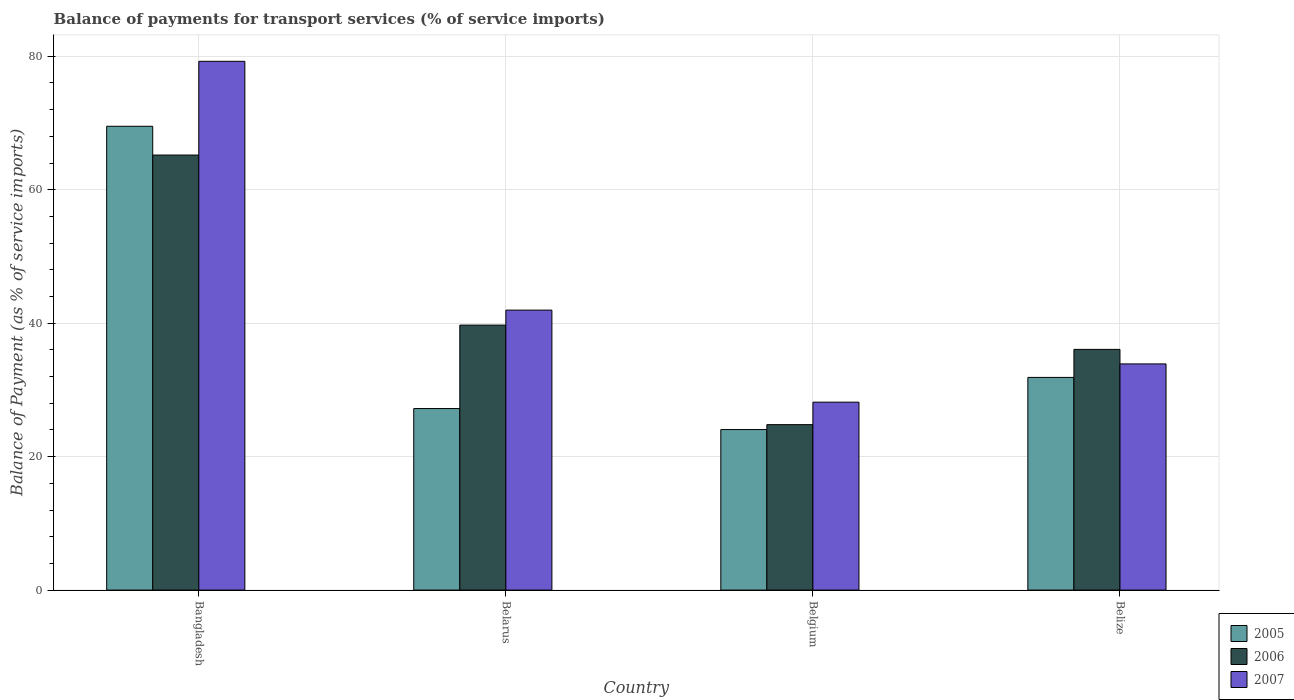How many different coloured bars are there?
Offer a terse response. 3. How many bars are there on the 3rd tick from the left?
Your answer should be very brief. 3. What is the balance of payments for transport services in 2006 in Belize?
Provide a short and direct response. 36.07. Across all countries, what is the maximum balance of payments for transport services in 2007?
Ensure brevity in your answer.  79.24. Across all countries, what is the minimum balance of payments for transport services in 2006?
Ensure brevity in your answer.  24.79. What is the total balance of payments for transport services in 2007 in the graph?
Provide a succinct answer. 183.25. What is the difference between the balance of payments for transport services in 2005 in Belarus and that in Belize?
Offer a terse response. -4.67. What is the difference between the balance of payments for transport services in 2005 in Belize and the balance of payments for transport services in 2006 in Belgium?
Your response must be concise. 7.08. What is the average balance of payments for transport services in 2006 per country?
Your answer should be very brief. 41.44. What is the difference between the balance of payments for transport services of/in 2007 and balance of payments for transport services of/in 2006 in Belize?
Your response must be concise. -2.18. What is the ratio of the balance of payments for transport services in 2007 in Bangladesh to that in Belgium?
Your answer should be very brief. 2.81. What is the difference between the highest and the second highest balance of payments for transport services in 2005?
Offer a terse response. -42.3. What is the difference between the highest and the lowest balance of payments for transport services in 2005?
Your answer should be very brief. 45.45. What does the 2nd bar from the left in Bangladesh represents?
Keep it short and to the point. 2006. What does the 2nd bar from the right in Belgium represents?
Offer a very short reply. 2006. Is it the case that in every country, the sum of the balance of payments for transport services in 2006 and balance of payments for transport services in 2005 is greater than the balance of payments for transport services in 2007?
Your answer should be compact. Yes. How many bars are there?
Your answer should be very brief. 12. How many countries are there in the graph?
Offer a terse response. 4. How are the legend labels stacked?
Keep it short and to the point. Vertical. What is the title of the graph?
Your answer should be very brief. Balance of payments for transport services (% of service imports). What is the label or title of the X-axis?
Your answer should be very brief. Country. What is the label or title of the Y-axis?
Make the answer very short. Balance of Payment (as % of service imports). What is the Balance of Payment (as % of service imports) in 2005 in Bangladesh?
Your answer should be very brief. 69.5. What is the Balance of Payment (as % of service imports) in 2006 in Bangladesh?
Ensure brevity in your answer.  65.2. What is the Balance of Payment (as % of service imports) of 2007 in Bangladesh?
Offer a terse response. 79.24. What is the Balance of Payment (as % of service imports) in 2005 in Belarus?
Your answer should be compact. 27.2. What is the Balance of Payment (as % of service imports) of 2006 in Belarus?
Your answer should be very brief. 39.71. What is the Balance of Payment (as % of service imports) of 2007 in Belarus?
Ensure brevity in your answer.  41.96. What is the Balance of Payment (as % of service imports) in 2005 in Belgium?
Give a very brief answer. 24.06. What is the Balance of Payment (as % of service imports) in 2006 in Belgium?
Give a very brief answer. 24.79. What is the Balance of Payment (as % of service imports) in 2007 in Belgium?
Give a very brief answer. 28.16. What is the Balance of Payment (as % of service imports) in 2005 in Belize?
Offer a very short reply. 31.87. What is the Balance of Payment (as % of service imports) in 2006 in Belize?
Your answer should be very brief. 36.07. What is the Balance of Payment (as % of service imports) of 2007 in Belize?
Make the answer very short. 33.89. Across all countries, what is the maximum Balance of Payment (as % of service imports) in 2005?
Provide a short and direct response. 69.5. Across all countries, what is the maximum Balance of Payment (as % of service imports) of 2006?
Your answer should be very brief. 65.2. Across all countries, what is the maximum Balance of Payment (as % of service imports) of 2007?
Ensure brevity in your answer.  79.24. Across all countries, what is the minimum Balance of Payment (as % of service imports) of 2005?
Provide a succinct answer. 24.06. Across all countries, what is the minimum Balance of Payment (as % of service imports) in 2006?
Your answer should be very brief. 24.79. Across all countries, what is the minimum Balance of Payment (as % of service imports) of 2007?
Your answer should be compact. 28.16. What is the total Balance of Payment (as % of service imports) in 2005 in the graph?
Keep it short and to the point. 152.64. What is the total Balance of Payment (as % of service imports) of 2006 in the graph?
Your answer should be compact. 165.77. What is the total Balance of Payment (as % of service imports) in 2007 in the graph?
Your answer should be compact. 183.25. What is the difference between the Balance of Payment (as % of service imports) in 2005 in Bangladesh and that in Belarus?
Your response must be concise. 42.3. What is the difference between the Balance of Payment (as % of service imports) of 2006 in Bangladesh and that in Belarus?
Make the answer very short. 25.48. What is the difference between the Balance of Payment (as % of service imports) in 2007 in Bangladesh and that in Belarus?
Your answer should be very brief. 37.28. What is the difference between the Balance of Payment (as % of service imports) in 2005 in Bangladesh and that in Belgium?
Your answer should be very brief. 45.45. What is the difference between the Balance of Payment (as % of service imports) of 2006 in Bangladesh and that in Belgium?
Offer a terse response. 40.4. What is the difference between the Balance of Payment (as % of service imports) in 2007 in Bangladesh and that in Belgium?
Offer a terse response. 51.08. What is the difference between the Balance of Payment (as % of service imports) of 2005 in Bangladesh and that in Belize?
Offer a very short reply. 37.63. What is the difference between the Balance of Payment (as % of service imports) of 2006 in Bangladesh and that in Belize?
Your answer should be compact. 29.12. What is the difference between the Balance of Payment (as % of service imports) of 2007 in Bangladesh and that in Belize?
Ensure brevity in your answer.  45.35. What is the difference between the Balance of Payment (as % of service imports) in 2005 in Belarus and that in Belgium?
Make the answer very short. 3.15. What is the difference between the Balance of Payment (as % of service imports) in 2006 in Belarus and that in Belgium?
Offer a very short reply. 14.92. What is the difference between the Balance of Payment (as % of service imports) in 2007 in Belarus and that in Belgium?
Your answer should be compact. 13.79. What is the difference between the Balance of Payment (as % of service imports) in 2005 in Belarus and that in Belize?
Offer a terse response. -4.67. What is the difference between the Balance of Payment (as % of service imports) of 2006 in Belarus and that in Belize?
Keep it short and to the point. 3.64. What is the difference between the Balance of Payment (as % of service imports) of 2007 in Belarus and that in Belize?
Provide a short and direct response. 8.06. What is the difference between the Balance of Payment (as % of service imports) in 2005 in Belgium and that in Belize?
Your answer should be very brief. -7.81. What is the difference between the Balance of Payment (as % of service imports) in 2006 in Belgium and that in Belize?
Your answer should be compact. -11.28. What is the difference between the Balance of Payment (as % of service imports) in 2007 in Belgium and that in Belize?
Ensure brevity in your answer.  -5.73. What is the difference between the Balance of Payment (as % of service imports) of 2005 in Bangladesh and the Balance of Payment (as % of service imports) of 2006 in Belarus?
Make the answer very short. 29.79. What is the difference between the Balance of Payment (as % of service imports) in 2005 in Bangladesh and the Balance of Payment (as % of service imports) in 2007 in Belarus?
Offer a terse response. 27.55. What is the difference between the Balance of Payment (as % of service imports) of 2006 in Bangladesh and the Balance of Payment (as % of service imports) of 2007 in Belarus?
Your answer should be compact. 23.24. What is the difference between the Balance of Payment (as % of service imports) of 2005 in Bangladesh and the Balance of Payment (as % of service imports) of 2006 in Belgium?
Your response must be concise. 44.71. What is the difference between the Balance of Payment (as % of service imports) of 2005 in Bangladesh and the Balance of Payment (as % of service imports) of 2007 in Belgium?
Offer a very short reply. 41.34. What is the difference between the Balance of Payment (as % of service imports) in 2006 in Bangladesh and the Balance of Payment (as % of service imports) in 2007 in Belgium?
Offer a terse response. 37.03. What is the difference between the Balance of Payment (as % of service imports) in 2005 in Bangladesh and the Balance of Payment (as % of service imports) in 2006 in Belize?
Your response must be concise. 33.43. What is the difference between the Balance of Payment (as % of service imports) in 2005 in Bangladesh and the Balance of Payment (as % of service imports) in 2007 in Belize?
Ensure brevity in your answer.  35.61. What is the difference between the Balance of Payment (as % of service imports) in 2006 in Bangladesh and the Balance of Payment (as % of service imports) in 2007 in Belize?
Your response must be concise. 31.3. What is the difference between the Balance of Payment (as % of service imports) of 2005 in Belarus and the Balance of Payment (as % of service imports) of 2006 in Belgium?
Offer a very short reply. 2.41. What is the difference between the Balance of Payment (as % of service imports) of 2005 in Belarus and the Balance of Payment (as % of service imports) of 2007 in Belgium?
Offer a very short reply. -0.96. What is the difference between the Balance of Payment (as % of service imports) of 2006 in Belarus and the Balance of Payment (as % of service imports) of 2007 in Belgium?
Provide a short and direct response. 11.55. What is the difference between the Balance of Payment (as % of service imports) of 2005 in Belarus and the Balance of Payment (as % of service imports) of 2006 in Belize?
Ensure brevity in your answer.  -8.87. What is the difference between the Balance of Payment (as % of service imports) in 2005 in Belarus and the Balance of Payment (as % of service imports) in 2007 in Belize?
Make the answer very short. -6.69. What is the difference between the Balance of Payment (as % of service imports) of 2006 in Belarus and the Balance of Payment (as % of service imports) of 2007 in Belize?
Keep it short and to the point. 5.82. What is the difference between the Balance of Payment (as % of service imports) in 2005 in Belgium and the Balance of Payment (as % of service imports) in 2006 in Belize?
Your response must be concise. -12.02. What is the difference between the Balance of Payment (as % of service imports) of 2005 in Belgium and the Balance of Payment (as % of service imports) of 2007 in Belize?
Keep it short and to the point. -9.84. What is the difference between the Balance of Payment (as % of service imports) in 2006 in Belgium and the Balance of Payment (as % of service imports) in 2007 in Belize?
Your response must be concise. -9.1. What is the average Balance of Payment (as % of service imports) in 2005 per country?
Give a very brief answer. 38.16. What is the average Balance of Payment (as % of service imports) of 2006 per country?
Your answer should be very brief. 41.44. What is the average Balance of Payment (as % of service imports) in 2007 per country?
Ensure brevity in your answer.  45.81. What is the difference between the Balance of Payment (as % of service imports) of 2005 and Balance of Payment (as % of service imports) of 2006 in Bangladesh?
Provide a succinct answer. 4.31. What is the difference between the Balance of Payment (as % of service imports) in 2005 and Balance of Payment (as % of service imports) in 2007 in Bangladesh?
Offer a terse response. -9.74. What is the difference between the Balance of Payment (as % of service imports) in 2006 and Balance of Payment (as % of service imports) in 2007 in Bangladesh?
Provide a succinct answer. -14.04. What is the difference between the Balance of Payment (as % of service imports) in 2005 and Balance of Payment (as % of service imports) in 2006 in Belarus?
Keep it short and to the point. -12.51. What is the difference between the Balance of Payment (as % of service imports) of 2005 and Balance of Payment (as % of service imports) of 2007 in Belarus?
Provide a short and direct response. -14.75. What is the difference between the Balance of Payment (as % of service imports) in 2006 and Balance of Payment (as % of service imports) in 2007 in Belarus?
Make the answer very short. -2.24. What is the difference between the Balance of Payment (as % of service imports) in 2005 and Balance of Payment (as % of service imports) in 2006 in Belgium?
Offer a terse response. -0.74. What is the difference between the Balance of Payment (as % of service imports) of 2005 and Balance of Payment (as % of service imports) of 2007 in Belgium?
Make the answer very short. -4.11. What is the difference between the Balance of Payment (as % of service imports) of 2006 and Balance of Payment (as % of service imports) of 2007 in Belgium?
Keep it short and to the point. -3.37. What is the difference between the Balance of Payment (as % of service imports) in 2005 and Balance of Payment (as % of service imports) in 2006 in Belize?
Your answer should be very brief. -4.2. What is the difference between the Balance of Payment (as % of service imports) in 2005 and Balance of Payment (as % of service imports) in 2007 in Belize?
Your response must be concise. -2.02. What is the difference between the Balance of Payment (as % of service imports) of 2006 and Balance of Payment (as % of service imports) of 2007 in Belize?
Make the answer very short. 2.18. What is the ratio of the Balance of Payment (as % of service imports) of 2005 in Bangladesh to that in Belarus?
Your answer should be very brief. 2.55. What is the ratio of the Balance of Payment (as % of service imports) in 2006 in Bangladesh to that in Belarus?
Offer a very short reply. 1.64. What is the ratio of the Balance of Payment (as % of service imports) of 2007 in Bangladesh to that in Belarus?
Offer a very short reply. 1.89. What is the ratio of the Balance of Payment (as % of service imports) of 2005 in Bangladesh to that in Belgium?
Ensure brevity in your answer.  2.89. What is the ratio of the Balance of Payment (as % of service imports) in 2006 in Bangladesh to that in Belgium?
Ensure brevity in your answer.  2.63. What is the ratio of the Balance of Payment (as % of service imports) in 2007 in Bangladesh to that in Belgium?
Provide a short and direct response. 2.81. What is the ratio of the Balance of Payment (as % of service imports) of 2005 in Bangladesh to that in Belize?
Offer a terse response. 2.18. What is the ratio of the Balance of Payment (as % of service imports) of 2006 in Bangladesh to that in Belize?
Give a very brief answer. 1.81. What is the ratio of the Balance of Payment (as % of service imports) in 2007 in Bangladesh to that in Belize?
Your response must be concise. 2.34. What is the ratio of the Balance of Payment (as % of service imports) of 2005 in Belarus to that in Belgium?
Your answer should be compact. 1.13. What is the ratio of the Balance of Payment (as % of service imports) of 2006 in Belarus to that in Belgium?
Provide a short and direct response. 1.6. What is the ratio of the Balance of Payment (as % of service imports) in 2007 in Belarus to that in Belgium?
Your response must be concise. 1.49. What is the ratio of the Balance of Payment (as % of service imports) of 2005 in Belarus to that in Belize?
Provide a short and direct response. 0.85. What is the ratio of the Balance of Payment (as % of service imports) of 2006 in Belarus to that in Belize?
Your answer should be compact. 1.1. What is the ratio of the Balance of Payment (as % of service imports) in 2007 in Belarus to that in Belize?
Provide a short and direct response. 1.24. What is the ratio of the Balance of Payment (as % of service imports) in 2005 in Belgium to that in Belize?
Provide a short and direct response. 0.75. What is the ratio of the Balance of Payment (as % of service imports) in 2006 in Belgium to that in Belize?
Your answer should be compact. 0.69. What is the ratio of the Balance of Payment (as % of service imports) of 2007 in Belgium to that in Belize?
Your answer should be very brief. 0.83. What is the difference between the highest and the second highest Balance of Payment (as % of service imports) in 2005?
Keep it short and to the point. 37.63. What is the difference between the highest and the second highest Balance of Payment (as % of service imports) in 2006?
Give a very brief answer. 25.48. What is the difference between the highest and the second highest Balance of Payment (as % of service imports) in 2007?
Give a very brief answer. 37.28. What is the difference between the highest and the lowest Balance of Payment (as % of service imports) in 2005?
Keep it short and to the point. 45.45. What is the difference between the highest and the lowest Balance of Payment (as % of service imports) in 2006?
Offer a terse response. 40.4. What is the difference between the highest and the lowest Balance of Payment (as % of service imports) of 2007?
Make the answer very short. 51.08. 